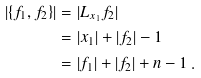<formula> <loc_0><loc_0><loc_500><loc_500>| \{ f _ { 1 } , f _ { 2 } \} | & = | L _ { x _ { 1 } } f _ { 2 } | \\ & = | x _ { 1 } | + | f _ { 2 } | - 1 \\ & = | f _ { 1 } | + | f _ { 2 } | + n - 1 \, .</formula> 